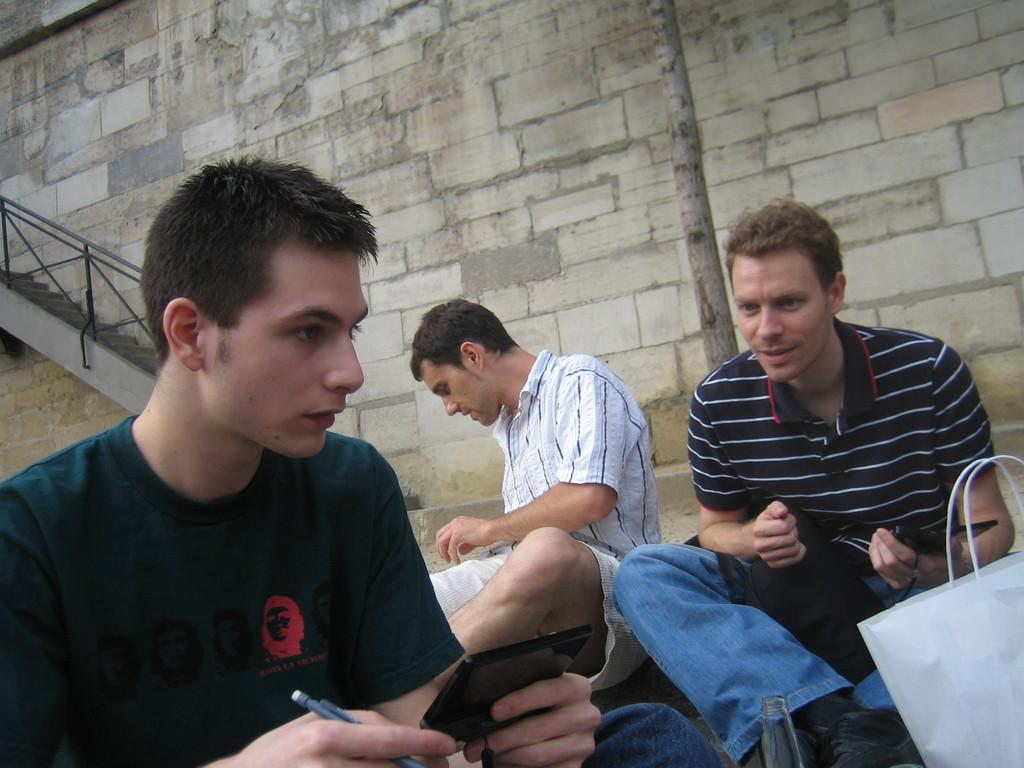What is the man holding in his hand in the image? The man is holding a pen in his hand in the image. Can you describe the object the man is holding? The object appears to be black. What can be seen in the background of the image? There is a person, railings, and a wall in the background of the image. How many geese are visible on the side of the wall in the image? There are no geese present in the image, and the wall does not have any geese visible on its side. 